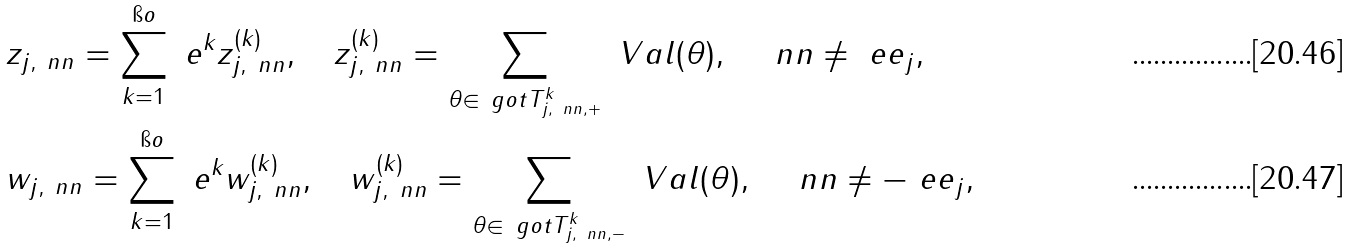<formula> <loc_0><loc_0><loc_500><loc_500>& { z } _ { j , \ n n } = \sum _ { k = 1 } ^ { \i o } \ e ^ { k } z ^ { ( k ) } _ { j , \ n n } , \quad z ^ { ( k ) } _ { j , \ n n } = \sum _ { \theta \in \ g o t T ^ { k } _ { j , \ n n , + } } \ V a l ( \theta ) , \quad \ n n \neq \ e e _ { j } , \\ & { w } _ { j , \ n n } = \sum _ { k = 1 } ^ { \i o } \ e ^ { k } w ^ { ( k ) } _ { j , \ n n } , \quad w ^ { ( k ) } _ { j , \ n n } = \sum _ { \theta \in \ g o t T ^ { k } _ { j , \ n n , - } } \ V a l ( \theta ) , \quad \ n n \neq - \ e e _ { j } ,</formula> 